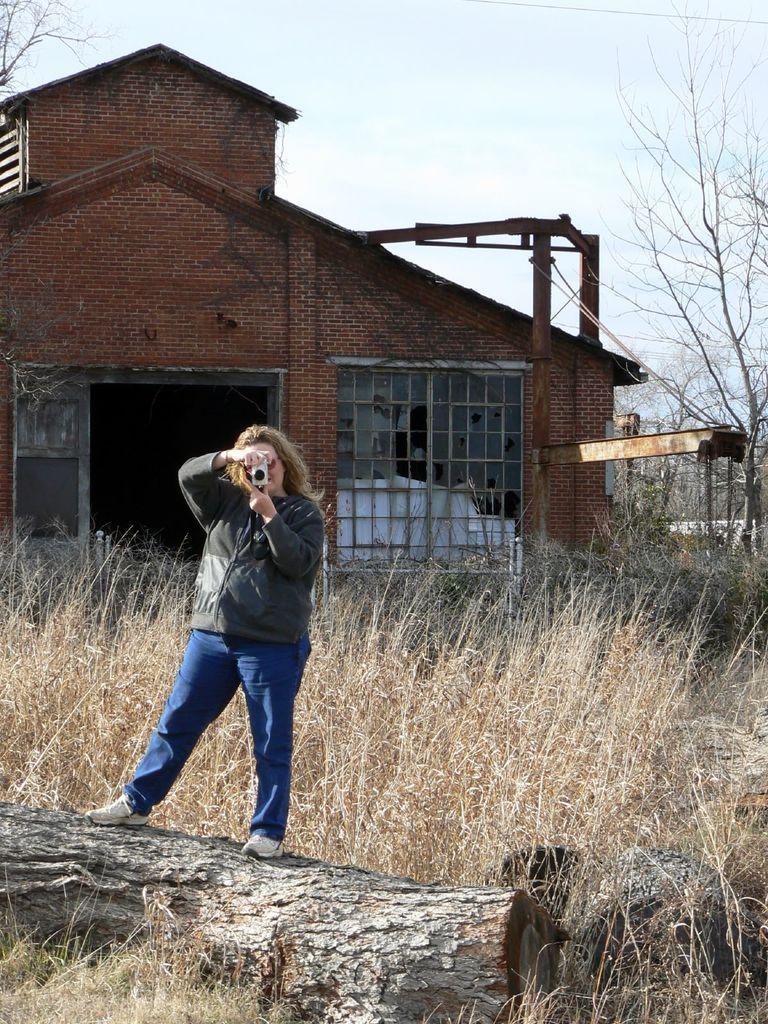Can you describe this image briefly? In this picture we can see a woman standing and holding a camera, at the bottom there is grass, we can see a building in the background, on the right side there is a tree, we can see the sky at the top of the picture. 